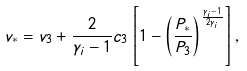Convert formula to latex. <formula><loc_0><loc_0><loc_500><loc_500>v _ { * } = v _ { 3 } + \frac { 2 } { \gamma _ { i } - 1 } c _ { 3 } \left [ 1 - \left ( \frac { P _ { * } } { P _ { 3 } } \right ) ^ { \frac { \gamma _ { i } - 1 } { 2 \gamma _ { i } } } \right ] ,</formula> 